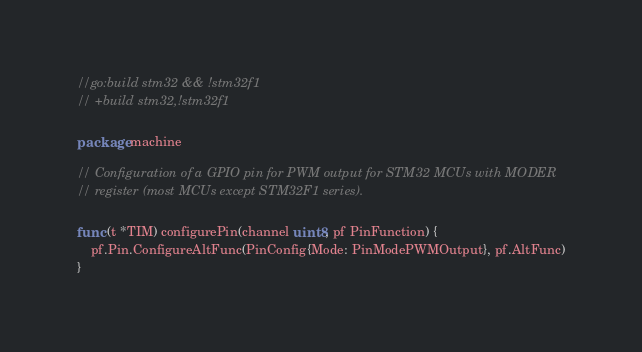<code> <loc_0><loc_0><loc_500><loc_500><_Go_>//go:build stm32 && !stm32f1
// +build stm32,!stm32f1

package machine

// Configuration of a GPIO pin for PWM output for STM32 MCUs with MODER
// register (most MCUs except STM32F1 series).

func (t *TIM) configurePin(channel uint8, pf PinFunction) {
	pf.Pin.ConfigureAltFunc(PinConfig{Mode: PinModePWMOutput}, pf.AltFunc)
}
</code> 